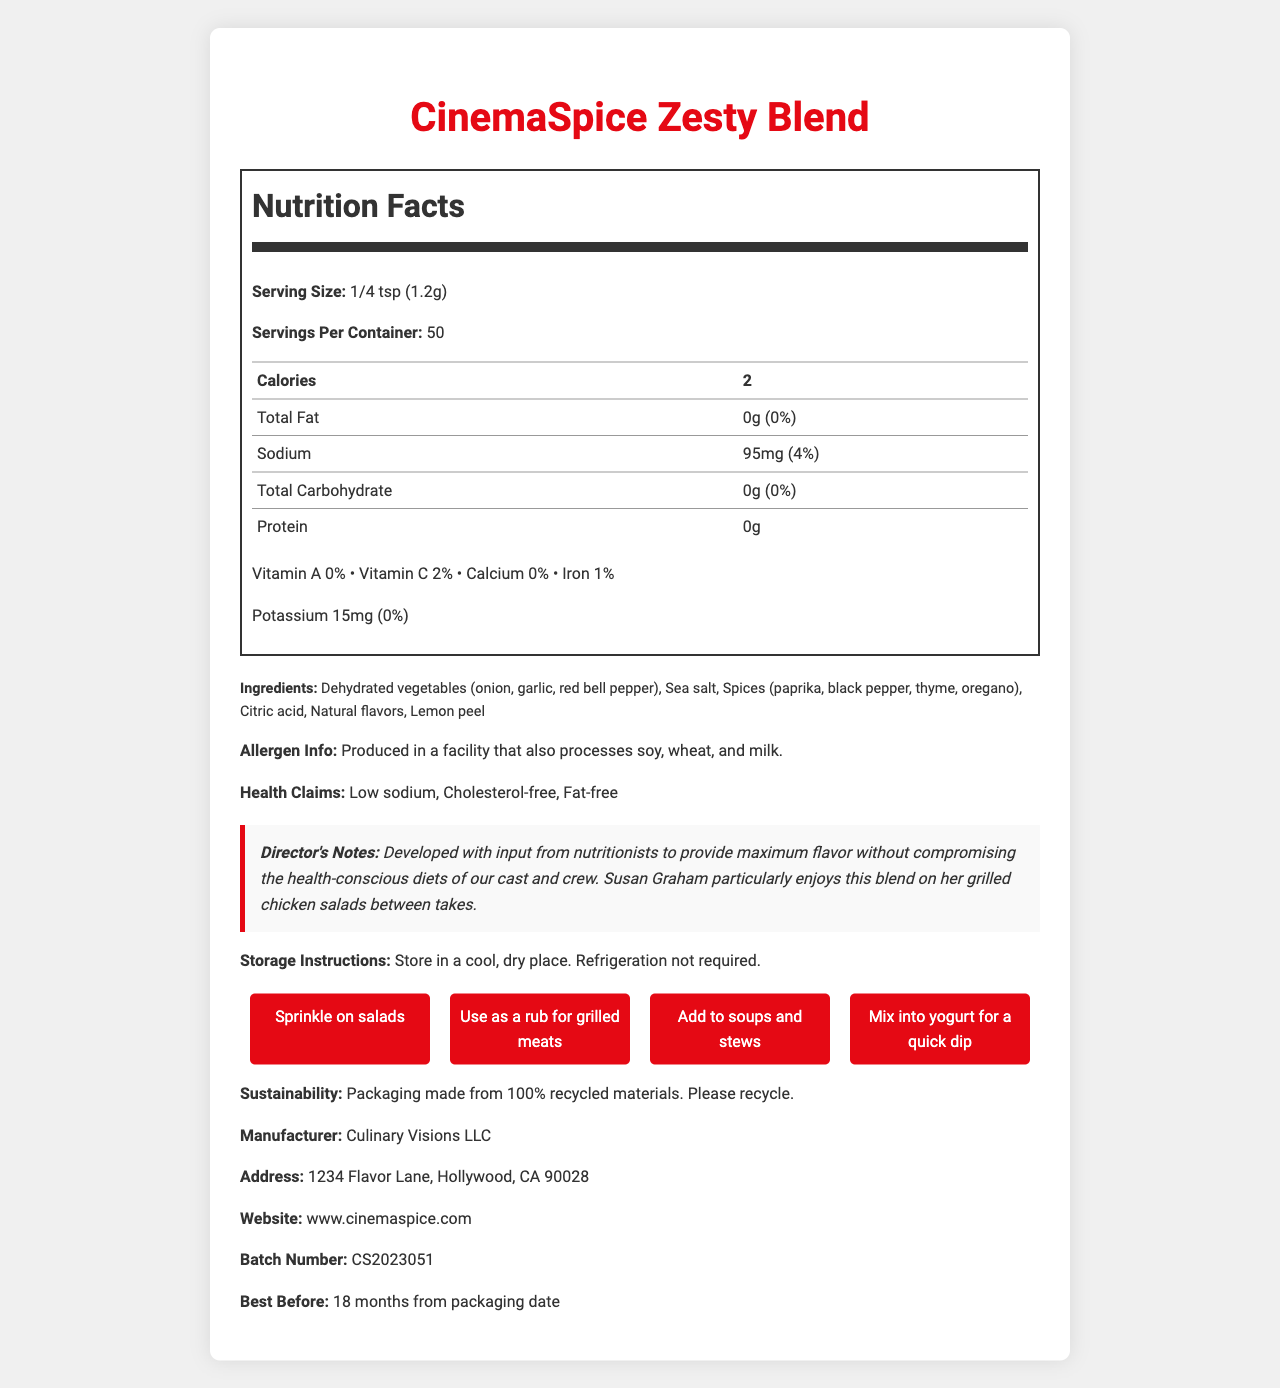what is the serving size for CinemaSpice Zesty Blend? The serving size is clearly listed in the Nutrition Facts section below the product name.
Answer: 1/4 tsp (1.2g) how many servings are in one container of CinemaSpice Zesty Blend? The document specifies "Servings Per Container: 50" in the Nutrition Facts section.
Answer: 50 what is the amount of sodium in one serving of CinemaSpice Zesty Blend? The document lists sodium content as 95mg per serving in the Nutrition Facts section.
Answer: 95mg what are the ingredients listed for CinemaSpice Zesty Blend? The ingredients are detailed under the Ingredients section.
Answer: Dehydrated vegetables (onion, garlic, red bell pepper), Sea salt, Spices (paprika, black pepper, thyme, oregano), Citric acid, Natural flavors, Lemon peel what is the best before date for CinemaSpice Zesty Blend? The best before date is mentioned at the bottom of the document.
Answer: 18 months from packaging date which health claim is not made about CinemaSpice Zesty Blend? A. Low sodium B. High fiber C. Cholesterol-free D. Fat-free The document lists the health claims as Low sodium, Cholesterol-free, and Fat-free.
Answer: B what percentage of the daily value of Vitamin C is provided by one serving? A. 4% B. 2% C. 1% D. 0% The document indicates that one serving provides 2% of the daily value of Vitamin C.
Answer: B is CinemaSpice Zesty Blend produced in a facility that processes soy? The Allergen Info section specifies that it is produced in a facility that also processes soy, wheat, and milk.
Answer: Yes are there any calories in CinemaSpice Zesty Blend? The Nutrition Facts label lists 2 calories per serving.
Answer: Yes summarize the main purpose of the document This document is designed to present comprehensive information about the seasoning mix, focusing on its nutritional benefits, ingredients, and appropriate uses. It also highlights its alignment with health-conscious eating habits on a film set.
Answer: The document provides detailed information about CinemaSpice Zesty Blend, a low-calorie, high-flavor seasoning mix. It includes Nutrition Facts, ingredients, allergen information, health claims, storage instructions, usage suggestions, sustainability info, and other relevant details. The director's notes mention the seasoning's suitability for health-conscious diets and its approval by Susan Graham. how much potassium does CinemaSpice Zesty Blend contain per serving? The Nutrition Facts label lists 15mg of potassium per serving.
Answer: 15mg is CinemaSpice Zesty Blend suitable for vegetarians? The document does not explicitly state whether the seasoning blend is suitable for vegetarians.
Answer: Cannot be determined what makes CinemaSpice Zesty Blend preferable for health-conscious diets according to the director's notes? The Director's Notes section mentions its developed input from nutritionists and Susan Graham's enjoyment, indicating its healthy profile while maintaining flavor.
Answer: It provides maximum flavor without compromising health-conscious diets of the cast and crew, and has been particularly enjoyed by Susan Graham on her grilled chicken salads. what is the function of citric acid in CinemaSpice Zesty Blend? The document lists citric acid as an ingredient but does not specify its function within the seasoning blend.
Answer: Cannot be determined 